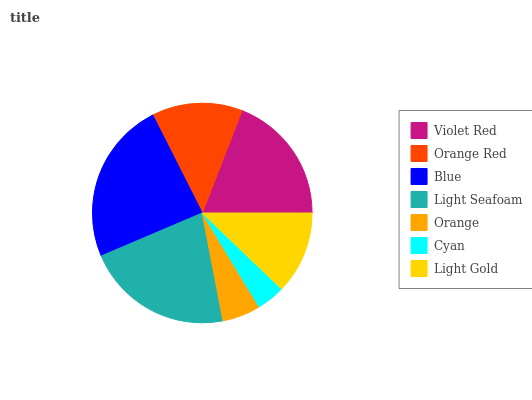Is Cyan the minimum?
Answer yes or no. Yes. Is Blue the maximum?
Answer yes or no. Yes. Is Orange Red the minimum?
Answer yes or no. No. Is Orange Red the maximum?
Answer yes or no. No. Is Violet Red greater than Orange Red?
Answer yes or no. Yes. Is Orange Red less than Violet Red?
Answer yes or no. Yes. Is Orange Red greater than Violet Red?
Answer yes or no. No. Is Violet Red less than Orange Red?
Answer yes or no. No. Is Orange Red the high median?
Answer yes or no. Yes. Is Orange Red the low median?
Answer yes or no. Yes. Is Orange the high median?
Answer yes or no. No. Is Blue the low median?
Answer yes or no. No. 